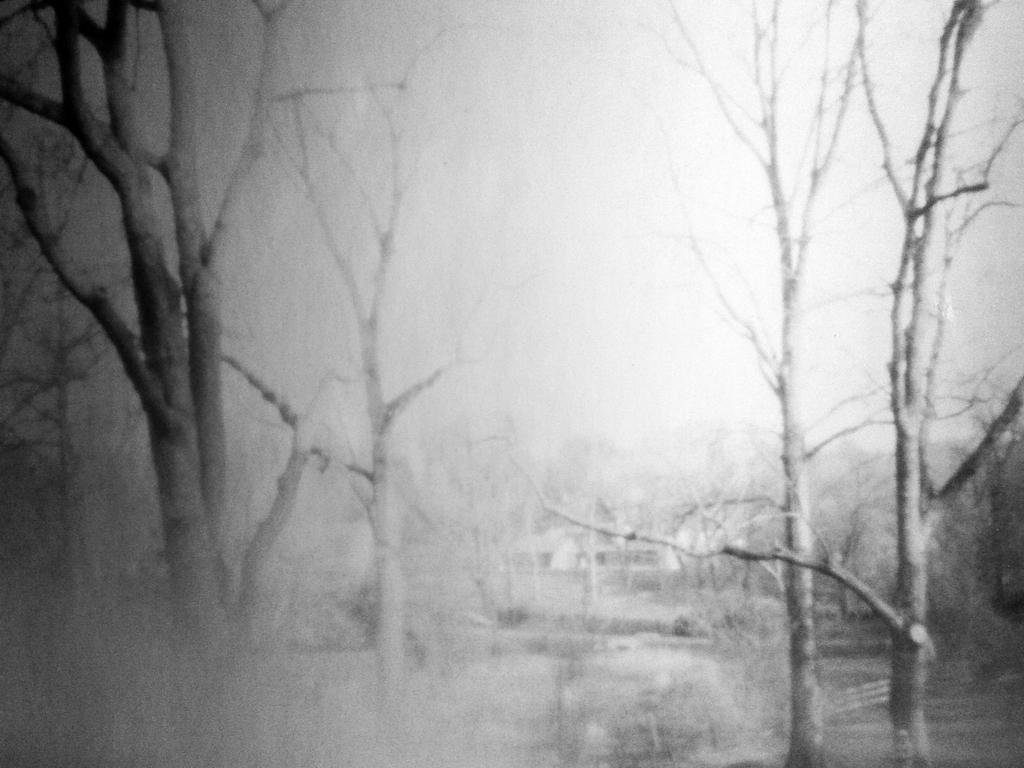What is the color scheme of the image? The image is black and white. What type of natural vegetation can be seen in the image? There are trees in the image. What word does the donkey say in the image? There is no donkey present in the image, so it is not possible to determine what word it might say. 